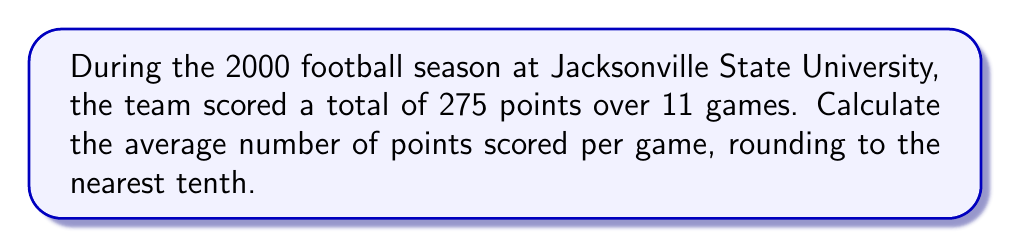Show me your answer to this math problem. To calculate the average points scored per game, we need to divide the total points scored by the number of games played.

Let's define our variables:
$T$ = Total points scored
$G$ = Number of games played
$A$ = Average points per game

We're given:
$T = 275$
$G = 11$

The formula for calculating the average is:

$$A = \frac{T}{G}$$

Substituting our values:

$$A = \frac{275}{11}$$

Using a calculator or long division:

$$A = 25.\overline{45}$$

Rounding to the nearest tenth:

$$A \approx 25.5$$
Answer: $25.5$ points per game 